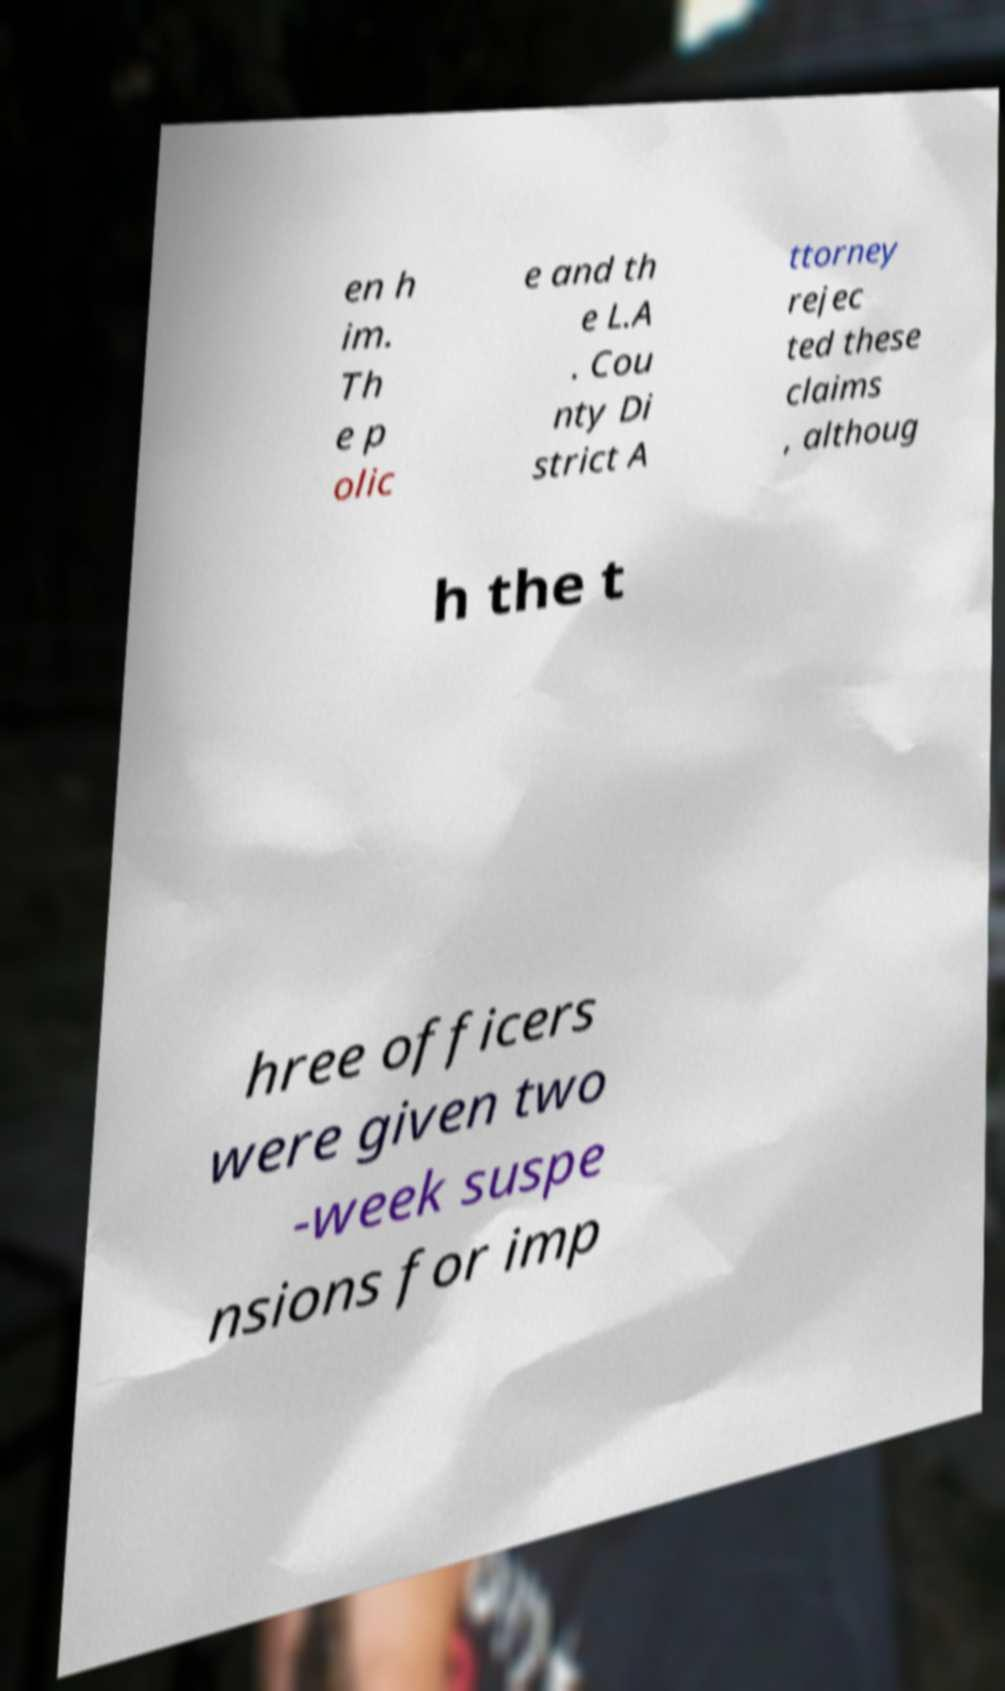There's text embedded in this image that I need extracted. Can you transcribe it verbatim? en h im. Th e p olic e and th e L.A . Cou nty Di strict A ttorney rejec ted these claims , althoug h the t hree officers were given two -week suspe nsions for imp 